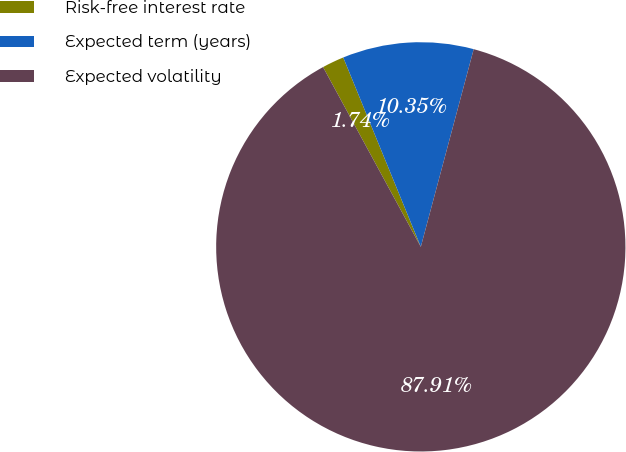<chart> <loc_0><loc_0><loc_500><loc_500><pie_chart><fcel>Risk-free interest rate<fcel>Expected term (years)<fcel>Expected volatility<nl><fcel>1.74%<fcel>10.35%<fcel>87.92%<nl></chart> 